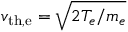<formula> <loc_0><loc_0><loc_500><loc_500>v _ { t h , e } = \sqrt { 2 T _ { e } / m _ { e } }</formula> 